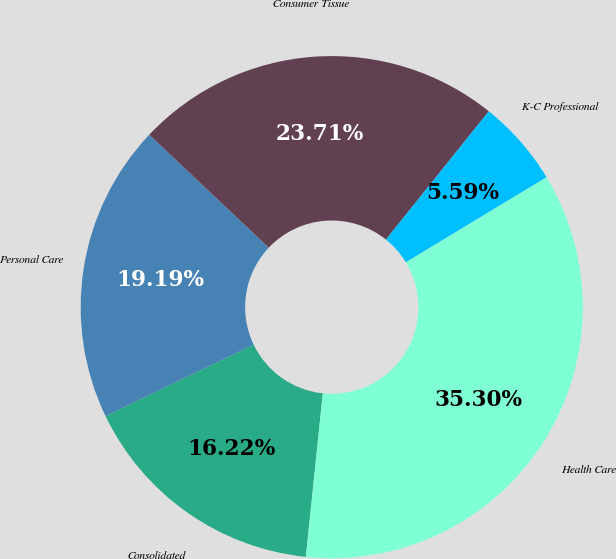Convert chart to OTSL. <chart><loc_0><loc_0><loc_500><loc_500><pie_chart><fcel>Consolidated<fcel>Personal Care<fcel>Consumer Tissue<fcel>K-C Professional<fcel>Health Care<nl><fcel>16.22%<fcel>19.19%<fcel>23.71%<fcel>5.59%<fcel>35.3%<nl></chart> 